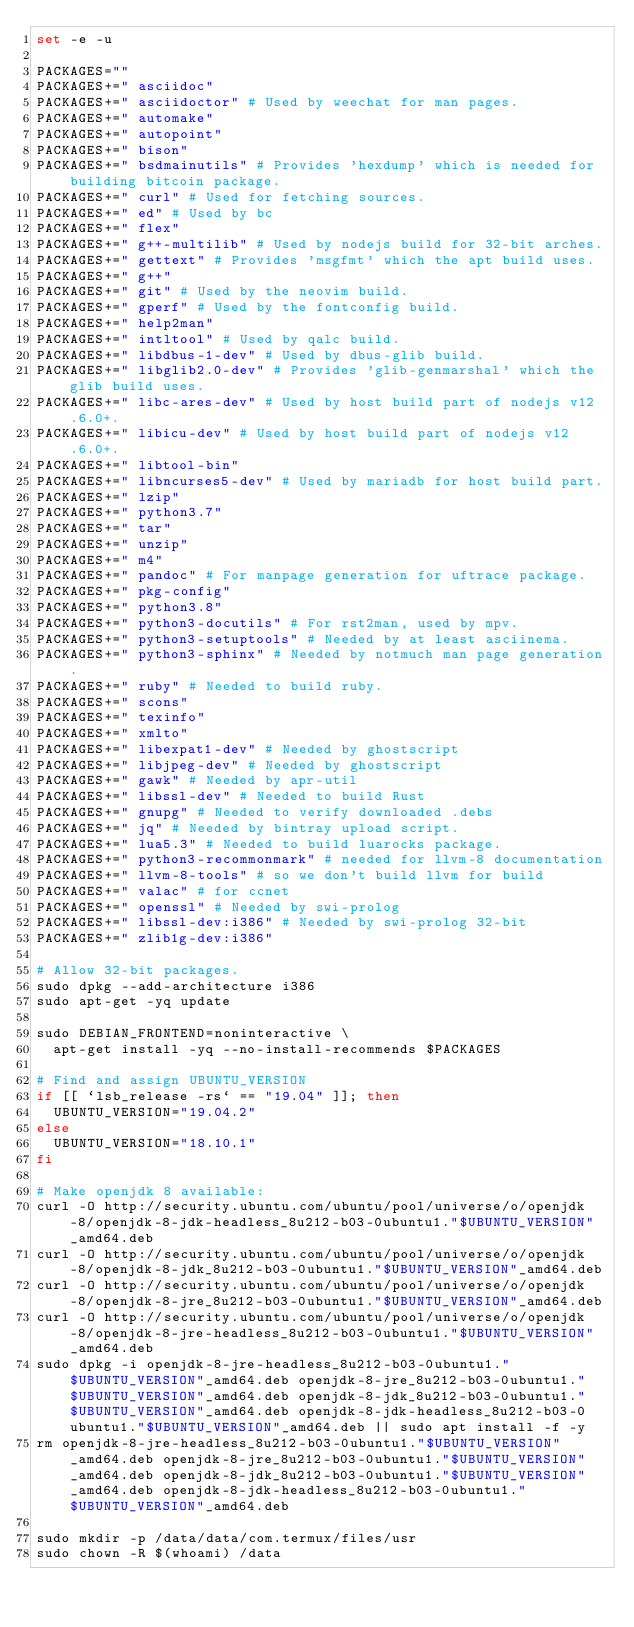<code> <loc_0><loc_0><loc_500><loc_500><_Bash_>set -e -u

PACKAGES=""
PACKAGES+=" asciidoc"
PACKAGES+=" asciidoctor" # Used by weechat for man pages.
PACKAGES+=" automake"
PACKAGES+=" autopoint"
PACKAGES+=" bison"
PACKAGES+=" bsdmainutils" # Provides 'hexdump' which is needed for building bitcoin package.
PACKAGES+=" curl" # Used for fetching sources.
PACKAGES+=" ed" # Used by bc
PACKAGES+=" flex"
PACKAGES+=" g++-multilib" # Used by nodejs build for 32-bit arches.
PACKAGES+=" gettext" # Provides 'msgfmt' which the apt build uses.
PACKAGES+=" g++"
PACKAGES+=" git" # Used by the neovim build.
PACKAGES+=" gperf" # Used by the fontconfig build.
PACKAGES+=" help2man"
PACKAGES+=" intltool" # Used by qalc build.
PACKAGES+=" libdbus-1-dev" # Used by dbus-glib build.
PACKAGES+=" libglib2.0-dev" # Provides 'glib-genmarshal' which the glib build uses.
PACKAGES+=" libc-ares-dev" # Used by host build part of nodejs v12.6.0+.
PACKAGES+=" libicu-dev" # Used by host build part of nodejs v12.6.0+.
PACKAGES+=" libtool-bin"
PACKAGES+=" libncurses5-dev" # Used by mariadb for host build part.
PACKAGES+=" lzip"
PACKAGES+=" python3.7"
PACKAGES+=" tar"
PACKAGES+=" unzip"
PACKAGES+=" m4"
PACKAGES+=" pandoc" # For manpage generation for uftrace package.
PACKAGES+=" pkg-config"
PACKAGES+=" python3.8"
PACKAGES+=" python3-docutils" # For rst2man, used by mpv.
PACKAGES+=" python3-setuptools" # Needed by at least asciinema.
PACKAGES+=" python3-sphinx" # Needed by notmuch man page generation.
PACKAGES+=" ruby" # Needed to build ruby.
PACKAGES+=" scons"
PACKAGES+=" texinfo"
PACKAGES+=" xmlto"
PACKAGES+=" libexpat1-dev" # Needed by ghostscript
PACKAGES+=" libjpeg-dev" # Needed by ghostscript
PACKAGES+=" gawk" # Needed by apr-util
PACKAGES+=" libssl-dev" # Needed to build Rust
PACKAGES+=" gnupg" # Needed to verify downloaded .debs
PACKAGES+=" jq" # Needed by bintray upload script.
PACKAGES+=" lua5.3" # Needed to build luarocks package.
PACKAGES+=" python3-recommonmark" # needed for llvm-8 documentation
PACKAGES+=" llvm-8-tools" # so we don't build llvm for build
PACKAGES+=" valac" # for ccnet
PACKAGES+=" openssl" # Needed by swi-prolog
PACKAGES+=" libssl-dev:i386" # Needed by swi-prolog 32-bit
PACKAGES+=" zlib1g-dev:i386"

# Allow 32-bit packages.
sudo dpkg --add-architecture i386
sudo apt-get -yq update

sudo DEBIAN_FRONTEND=noninteractive \
	apt-get install -yq --no-install-recommends $PACKAGES

# Find and assign UBUNTU_VERSION
if [[ `lsb_release -rs` == "19.04" ]]; then
	UBUNTU_VERSION="19.04.2"
else
	UBUNTU_VERSION="18.10.1"
fi

# Make openjdk 8 available:
curl -O http://security.ubuntu.com/ubuntu/pool/universe/o/openjdk-8/openjdk-8-jdk-headless_8u212-b03-0ubuntu1."$UBUNTU_VERSION"_amd64.deb
curl -O http://security.ubuntu.com/ubuntu/pool/universe/o/openjdk-8/openjdk-8-jdk_8u212-b03-0ubuntu1."$UBUNTU_VERSION"_amd64.deb
curl -O http://security.ubuntu.com/ubuntu/pool/universe/o/openjdk-8/openjdk-8-jre_8u212-b03-0ubuntu1."$UBUNTU_VERSION"_amd64.deb
curl -O http://security.ubuntu.com/ubuntu/pool/universe/o/openjdk-8/openjdk-8-jre-headless_8u212-b03-0ubuntu1."$UBUNTU_VERSION"_amd64.deb
sudo dpkg -i openjdk-8-jre-headless_8u212-b03-0ubuntu1."$UBUNTU_VERSION"_amd64.deb openjdk-8-jre_8u212-b03-0ubuntu1."$UBUNTU_VERSION"_amd64.deb openjdk-8-jdk_8u212-b03-0ubuntu1."$UBUNTU_VERSION"_amd64.deb openjdk-8-jdk-headless_8u212-b03-0ubuntu1."$UBUNTU_VERSION"_amd64.deb || sudo apt install -f -y
rm openjdk-8-jre-headless_8u212-b03-0ubuntu1."$UBUNTU_VERSION"_amd64.deb openjdk-8-jre_8u212-b03-0ubuntu1."$UBUNTU_VERSION"_amd64.deb openjdk-8-jdk_8u212-b03-0ubuntu1."$UBUNTU_VERSION"_amd64.deb openjdk-8-jdk-headless_8u212-b03-0ubuntu1."$UBUNTU_VERSION"_amd64.deb

sudo mkdir -p /data/data/com.termux/files/usr
sudo chown -R $(whoami) /data
</code> 